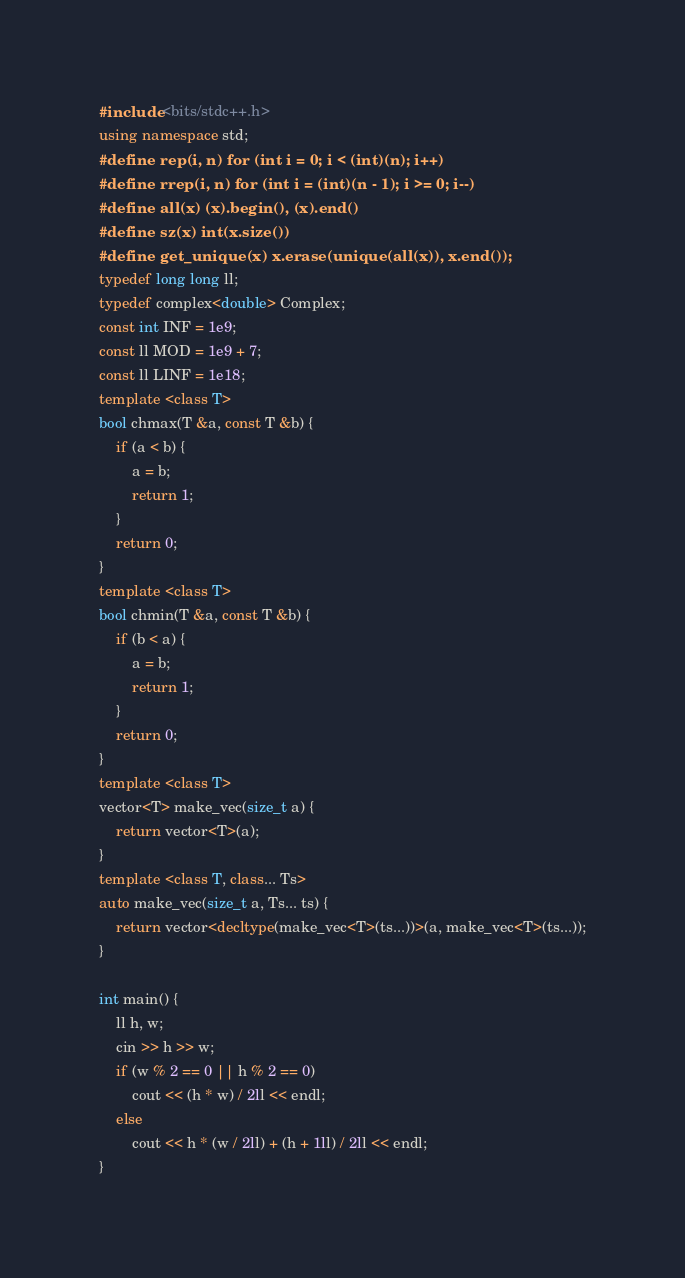<code> <loc_0><loc_0><loc_500><loc_500><_C++_>#include <bits/stdc++.h>
using namespace std;
#define rep(i, n) for (int i = 0; i < (int)(n); i++)
#define rrep(i, n) for (int i = (int)(n - 1); i >= 0; i--)
#define all(x) (x).begin(), (x).end()
#define sz(x) int(x.size())
#define get_unique(x) x.erase(unique(all(x)), x.end());
typedef long long ll;
typedef complex<double> Complex;
const int INF = 1e9;
const ll MOD = 1e9 + 7;
const ll LINF = 1e18;
template <class T>
bool chmax(T &a, const T &b) {
    if (a < b) {
        a = b;
        return 1;
    }
    return 0;
}
template <class T>
bool chmin(T &a, const T &b) {
    if (b < a) {
        a = b;
        return 1;
    }
    return 0;
}
template <class T>
vector<T> make_vec(size_t a) {
    return vector<T>(a);
}
template <class T, class... Ts>
auto make_vec(size_t a, Ts... ts) {
    return vector<decltype(make_vec<T>(ts...))>(a, make_vec<T>(ts...));
}

int main() {
    ll h, w;
    cin >> h >> w;
    if (w % 2 == 0 || h % 2 == 0)
        cout << (h * w) / 2ll << endl;
    else
        cout << h * (w / 2ll) + (h + 1ll) / 2ll << endl;
}
</code> 